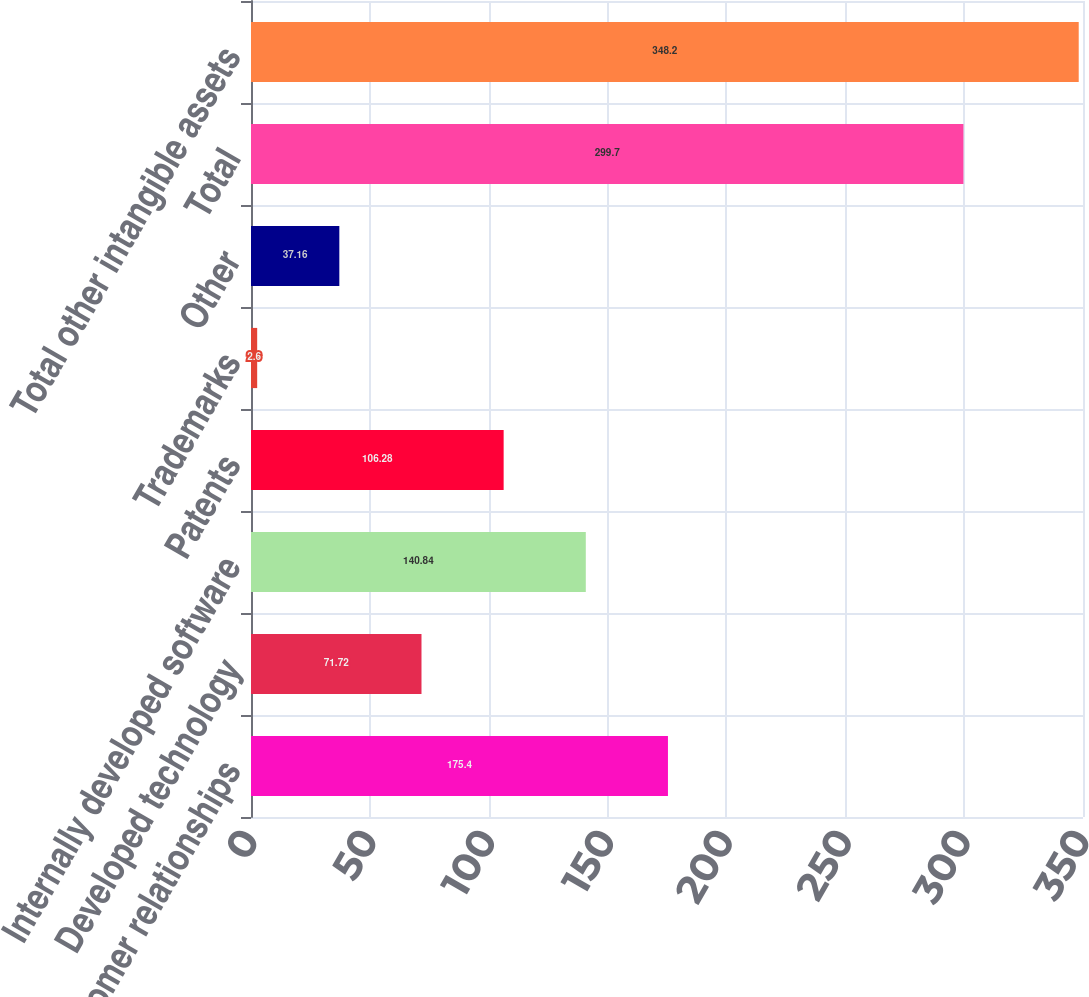Convert chart to OTSL. <chart><loc_0><loc_0><loc_500><loc_500><bar_chart><fcel>Customer relationships<fcel>Developed technology<fcel>Internally developed software<fcel>Patents<fcel>Trademarks<fcel>Other<fcel>Total<fcel>Total other intangible assets<nl><fcel>175.4<fcel>71.72<fcel>140.84<fcel>106.28<fcel>2.6<fcel>37.16<fcel>299.7<fcel>348.2<nl></chart> 